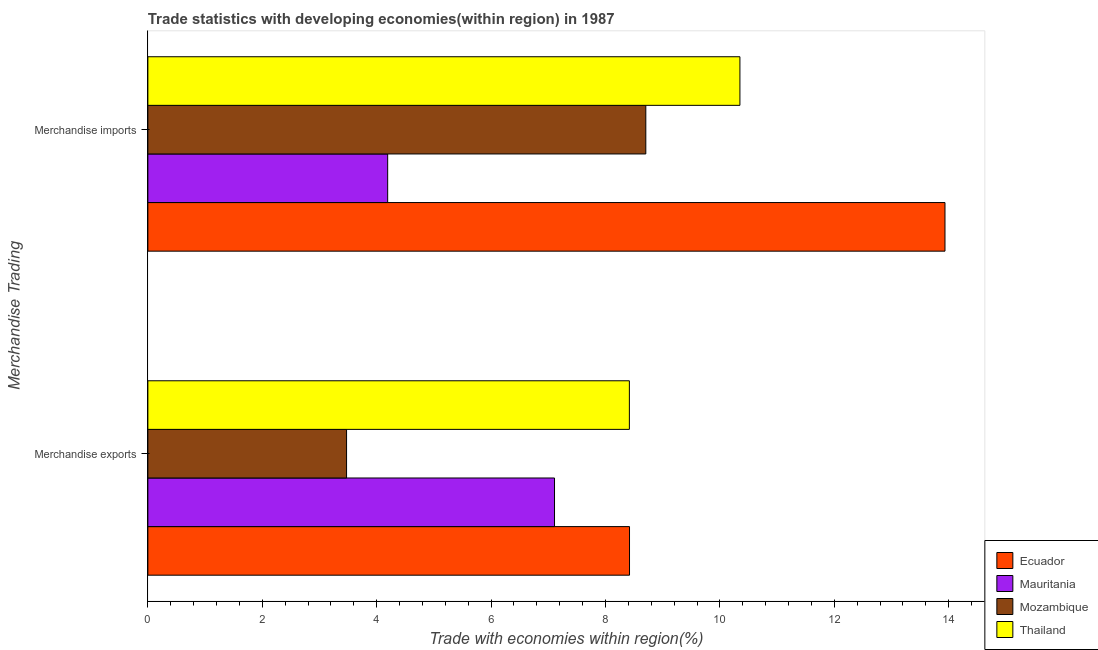Are the number of bars per tick equal to the number of legend labels?
Make the answer very short. Yes. Are the number of bars on each tick of the Y-axis equal?
Offer a terse response. Yes. How many bars are there on the 2nd tick from the bottom?
Offer a terse response. 4. What is the merchandise exports in Thailand?
Offer a very short reply. 8.42. Across all countries, what is the maximum merchandise imports?
Provide a succinct answer. 13.93. Across all countries, what is the minimum merchandise exports?
Offer a terse response. 3.47. In which country was the merchandise exports maximum?
Provide a short and direct response. Ecuador. In which country was the merchandise exports minimum?
Make the answer very short. Mozambique. What is the total merchandise exports in the graph?
Your answer should be very brief. 27.42. What is the difference between the merchandise exports in Thailand and that in Ecuador?
Provide a short and direct response. -0. What is the difference between the merchandise exports in Mozambique and the merchandise imports in Thailand?
Keep it short and to the point. -6.88. What is the average merchandise exports per country?
Ensure brevity in your answer.  6.85. What is the difference between the merchandise exports and merchandise imports in Mauritania?
Ensure brevity in your answer.  2.92. In how many countries, is the merchandise exports greater than 10.4 %?
Your response must be concise. 0. What is the ratio of the merchandise imports in Ecuador to that in Thailand?
Provide a short and direct response. 1.35. Is the merchandise imports in Thailand less than that in Ecuador?
Keep it short and to the point. Yes. What does the 1st bar from the top in Merchandise imports represents?
Offer a terse response. Thailand. What does the 1st bar from the bottom in Merchandise imports represents?
Your answer should be compact. Ecuador. Where does the legend appear in the graph?
Offer a very short reply. Bottom right. How are the legend labels stacked?
Provide a short and direct response. Vertical. What is the title of the graph?
Your answer should be very brief. Trade statistics with developing economies(within region) in 1987. What is the label or title of the X-axis?
Make the answer very short. Trade with economies within region(%). What is the label or title of the Y-axis?
Make the answer very short. Merchandise Trading. What is the Trade with economies within region(%) of Ecuador in Merchandise exports?
Ensure brevity in your answer.  8.42. What is the Trade with economies within region(%) in Mauritania in Merchandise exports?
Offer a very short reply. 7.11. What is the Trade with economies within region(%) in Mozambique in Merchandise exports?
Offer a very short reply. 3.47. What is the Trade with economies within region(%) in Thailand in Merchandise exports?
Provide a short and direct response. 8.42. What is the Trade with economies within region(%) in Ecuador in Merchandise imports?
Offer a very short reply. 13.93. What is the Trade with economies within region(%) in Mauritania in Merchandise imports?
Provide a succinct answer. 4.19. What is the Trade with economies within region(%) in Mozambique in Merchandise imports?
Your answer should be compact. 8.7. What is the Trade with economies within region(%) in Thailand in Merchandise imports?
Keep it short and to the point. 10.35. Across all Merchandise Trading, what is the maximum Trade with economies within region(%) in Ecuador?
Your answer should be compact. 13.93. Across all Merchandise Trading, what is the maximum Trade with economies within region(%) of Mauritania?
Give a very brief answer. 7.11. Across all Merchandise Trading, what is the maximum Trade with economies within region(%) of Mozambique?
Ensure brevity in your answer.  8.7. Across all Merchandise Trading, what is the maximum Trade with economies within region(%) of Thailand?
Your answer should be compact. 10.35. Across all Merchandise Trading, what is the minimum Trade with economies within region(%) of Ecuador?
Offer a terse response. 8.42. Across all Merchandise Trading, what is the minimum Trade with economies within region(%) of Mauritania?
Offer a terse response. 4.19. Across all Merchandise Trading, what is the minimum Trade with economies within region(%) of Mozambique?
Your answer should be very brief. 3.47. Across all Merchandise Trading, what is the minimum Trade with economies within region(%) in Thailand?
Make the answer very short. 8.42. What is the total Trade with economies within region(%) in Ecuador in the graph?
Make the answer very short. 22.35. What is the total Trade with economies within region(%) in Mauritania in the graph?
Your answer should be compact. 11.3. What is the total Trade with economies within region(%) of Mozambique in the graph?
Give a very brief answer. 12.18. What is the total Trade with economies within region(%) of Thailand in the graph?
Your answer should be very brief. 18.77. What is the difference between the Trade with economies within region(%) in Ecuador in Merchandise exports and that in Merchandise imports?
Your response must be concise. -5.51. What is the difference between the Trade with economies within region(%) in Mauritania in Merchandise exports and that in Merchandise imports?
Your answer should be compact. 2.92. What is the difference between the Trade with economies within region(%) in Mozambique in Merchandise exports and that in Merchandise imports?
Your response must be concise. -5.23. What is the difference between the Trade with economies within region(%) in Thailand in Merchandise exports and that in Merchandise imports?
Give a very brief answer. -1.93. What is the difference between the Trade with economies within region(%) in Ecuador in Merchandise exports and the Trade with economies within region(%) in Mauritania in Merchandise imports?
Ensure brevity in your answer.  4.23. What is the difference between the Trade with economies within region(%) in Ecuador in Merchandise exports and the Trade with economies within region(%) in Mozambique in Merchandise imports?
Offer a very short reply. -0.28. What is the difference between the Trade with economies within region(%) in Ecuador in Merchandise exports and the Trade with economies within region(%) in Thailand in Merchandise imports?
Provide a short and direct response. -1.93. What is the difference between the Trade with economies within region(%) of Mauritania in Merchandise exports and the Trade with economies within region(%) of Mozambique in Merchandise imports?
Give a very brief answer. -1.6. What is the difference between the Trade with economies within region(%) of Mauritania in Merchandise exports and the Trade with economies within region(%) of Thailand in Merchandise imports?
Keep it short and to the point. -3.24. What is the difference between the Trade with economies within region(%) of Mozambique in Merchandise exports and the Trade with economies within region(%) of Thailand in Merchandise imports?
Offer a very short reply. -6.88. What is the average Trade with economies within region(%) in Ecuador per Merchandise Trading?
Your answer should be very brief. 11.18. What is the average Trade with economies within region(%) in Mauritania per Merchandise Trading?
Offer a terse response. 5.65. What is the average Trade with economies within region(%) in Mozambique per Merchandise Trading?
Provide a succinct answer. 6.09. What is the average Trade with economies within region(%) in Thailand per Merchandise Trading?
Make the answer very short. 9.38. What is the difference between the Trade with economies within region(%) in Ecuador and Trade with economies within region(%) in Mauritania in Merchandise exports?
Ensure brevity in your answer.  1.31. What is the difference between the Trade with economies within region(%) in Ecuador and Trade with economies within region(%) in Mozambique in Merchandise exports?
Offer a very short reply. 4.95. What is the difference between the Trade with economies within region(%) in Ecuador and Trade with economies within region(%) in Thailand in Merchandise exports?
Offer a terse response. 0. What is the difference between the Trade with economies within region(%) in Mauritania and Trade with economies within region(%) in Mozambique in Merchandise exports?
Make the answer very short. 3.64. What is the difference between the Trade with economies within region(%) of Mauritania and Trade with economies within region(%) of Thailand in Merchandise exports?
Offer a terse response. -1.31. What is the difference between the Trade with economies within region(%) in Mozambique and Trade with economies within region(%) in Thailand in Merchandise exports?
Give a very brief answer. -4.94. What is the difference between the Trade with economies within region(%) in Ecuador and Trade with economies within region(%) in Mauritania in Merchandise imports?
Provide a short and direct response. 9.74. What is the difference between the Trade with economies within region(%) in Ecuador and Trade with economies within region(%) in Mozambique in Merchandise imports?
Your answer should be compact. 5.23. What is the difference between the Trade with economies within region(%) in Ecuador and Trade with economies within region(%) in Thailand in Merchandise imports?
Your answer should be very brief. 3.58. What is the difference between the Trade with economies within region(%) of Mauritania and Trade with economies within region(%) of Mozambique in Merchandise imports?
Your response must be concise. -4.51. What is the difference between the Trade with economies within region(%) of Mauritania and Trade with economies within region(%) of Thailand in Merchandise imports?
Keep it short and to the point. -6.16. What is the difference between the Trade with economies within region(%) in Mozambique and Trade with economies within region(%) in Thailand in Merchandise imports?
Make the answer very short. -1.65. What is the ratio of the Trade with economies within region(%) in Ecuador in Merchandise exports to that in Merchandise imports?
Your answer should be compact. 0.6. What is the ratio of the Trade with economies within region(%) of Mauritania in Merchandise exports to that in Merchandise imports?
Your answer should be compact. 1.7. What is the ratio of the Trade with economies within region(%) in Mozambique in Merchandise exports to that in Merchandise imports?
Keep it short and to the point. 0.4. What is the ratio of the Trade with economies within region(%) in Thailand in Merchandise exports to that in Merchandise imports?
Offer a very short reply. 0.81. What is the difference between the highest and the second highest Trade with economies within region(%) in Ecuador?
Ensure brevity in your answer.  5.51. What is the difference between the highest and the second highest Trade with economies within region(%) in Mauritania?
Your answer should be very brief. 2.92. What is the difference between the highest and the second highest Trade with economies within region(%) in Mozambique?
Provide a succinct answer. 5.23. What is the difference between the highest and the second highest Trade with economies within region(%) of Thailand?
Provide a succinct answer. 1.93. What is the difference between the highest and the lowest Trade with economies within region(%) in Ecuador?
Provide a short and direct response. 5.51. What is the difference between the highest and the lowest Trade with economies within region(%) of Mauritania?
Your response must be concise. 2.92. What is the difference between the highest and the lowest Trade with economies within region(%) of Mozambique?
Your answer should be very brief. 5.23. What is the difference between the highest and the lowest Trade with economies within region(%) in Thailand?
Give a very brief answer. 1.93. 